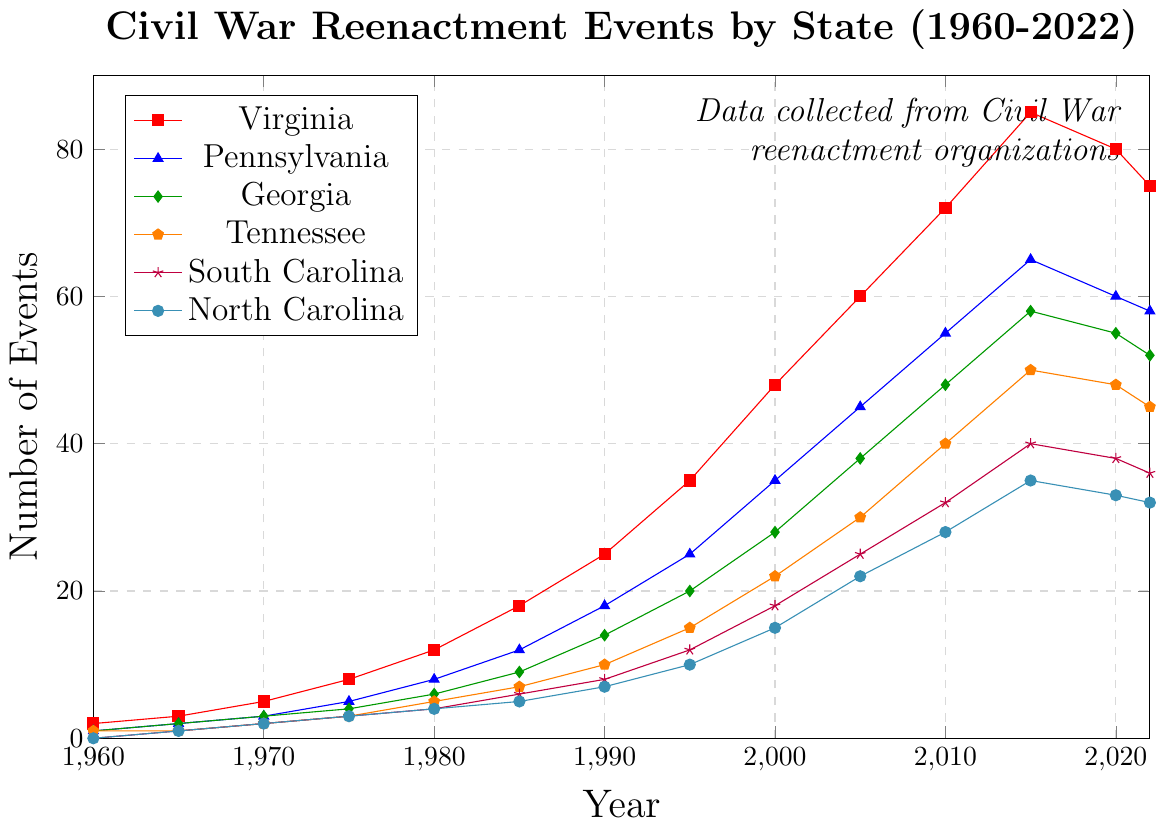What was the total number of Civil War reenactment events in all states in 1980? Sum the number of events for each state in 1980: Virginia (12) + Pennsylvania (8) + Georgia (6) + Tennessee (5) + South Carolina (4) + North Carolina (4) = 39
Answer: 39 Which state had the most substantial increase in the number of events between 1960 and 2015? Subtract the number of events in 1960 from the number of events in 2015 for each state and find the maximum difference: Virginia (85-2=83), Pennsylvania (65-1=64), Georgia (58-1=57), Tennessee (50-1=49), South Carolina (40-0=40), North Carolina (35-0=35). Virginia has the largest increase (83).
Answer: Virginia In which year did South Carolina have the same number of events as North Carolina? Compare the numbers in each year for South Carolina and North Carolina columns: both had 4 events in 1980.
Answer: 1980 Which state saw the largest decrease in the number of events from 2015 to 2020? Calculate the decrease in the number of events for each state from 2015 to 2020: Virginia (85-80=5), Pennsylvania (65-60=5), Georgia (58-55=3), Tennessee (50-48=2), South Carolina (40-38=2), North Carolina (35-33=2). Virginia and Pennsylvania have the largest decrease (5).
Answer: Virginia, Pennsylvania How many more events were held in Georgia than in Tennessee in the year 2000? The difference in the number of events between Georgia and Tennessee in 2000: Georgia (28) - Tennessee (22) = 6
Answer: 6 What is the average number of events held annually in Virginia from 1960 to 2022? Add the number of events in Virginia for each year and divide by the number of years: (2 + 3 + 5 + 8 + 12 + 18 + 25 + 35 + 48 + 60 + 72 + 85 + 80 + 75) / 14 = 528/14 ≈ 37.71
Answer: 37.71 Which year's data point stands out visually for Virginia compared to other states? Identify the year for Virginia where the number of events is significantly different than for other states. In 2015, Virginia had 85 events, which visually stands out as being much higher than any other state that year.
Answer: 2015 By how much did the number of events in Tennessee change from 1990 to 2010? Subtract the number of events in Tennessee in 1990 from the number in 2010: 40 - 10 = 30
Answer: 30 What can be seen about the trend of reenactment events in North Carolina from 2015 to 2022? Examine the data points for North Carolina from 2015 and 2022: there is a slight decrease from 35 events in 2015 to 32 events in 2022.
Answer: Decreasing In which decade did Pennsylvania see the most growth in the number of events? Calculate the growth for each decade by taking the difference between the end year and the start year: 1960s (3-1=2), 1970s (5-3=2), 1980s (12-5=7), 1990s (25-12=13), 2000s (45-35=10), 2010s (65-55=10). The largest growth occurs in the 1990s with 13.
Answer: 1990s 